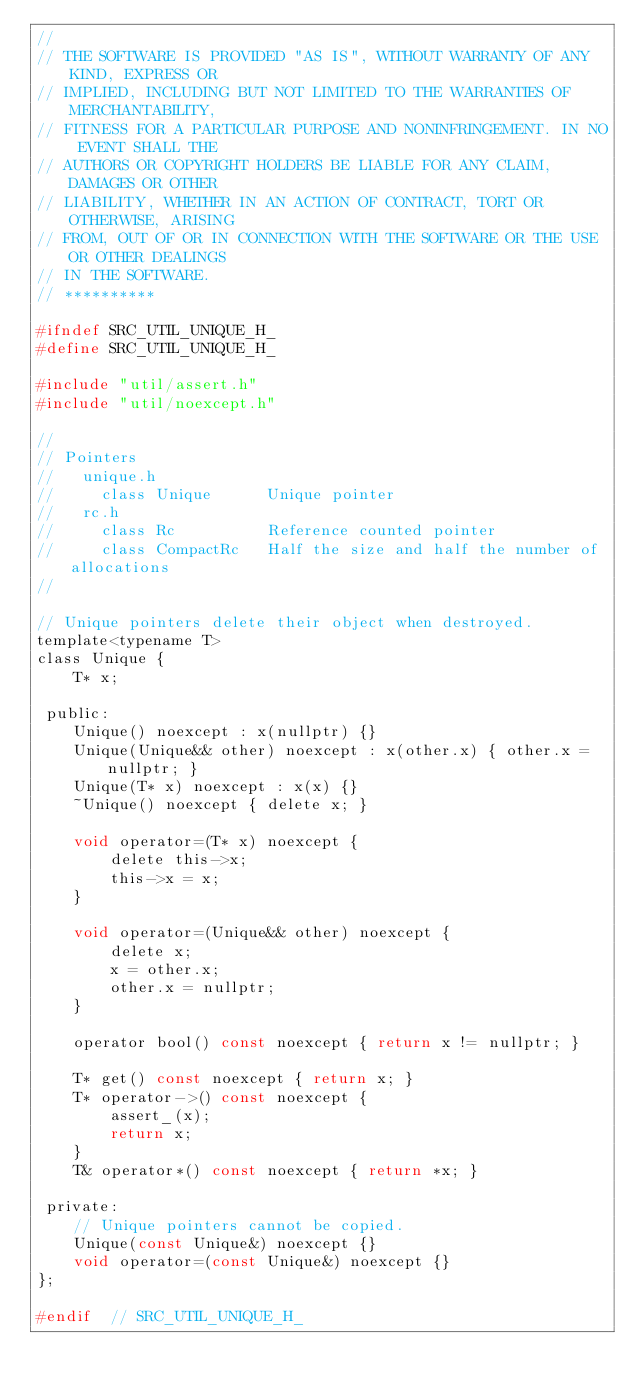Convert code to text. <code><loc_0><loc_0><loc_500><loc_500><_C_>//
// THE SOFTWARE IS PROVIDED "AS IS", WITHOUT WARRANTY OF ANY KIND, EXPRESS OR
// IMPLIED, INCLUDING BUT NOT LIMITED TO THE WARRANTIES OF MERCHANTABILITY,
// FITNESS FOR A PARTICULAR PURPOSE AND NONINFRINGEMENT. IN NO EVENT SHALL THE
// AUTHORS OR COPYRIGHT HOLDERS BE LIABLE FOR ANY CLAIM, DAMAGES OR OTHER
// LIABILITY, WHETHER IN AN ACTION OF CONTRACT, TORT OR OTHERWISE, ARISING
// FROM, OUT OF OR IN CONNECTION WITH THE SOFTWARE OR THE USE OR OTHER DEALINGS
// IN THE SOFTWARE.
// **********

#ifndef SRC_UTIL_UNIQUE_H_
#define SRC_UTIL_UNIQUE_H_

#include "util/assert.h"
#include "util/noexcept.h"

//
// Pointers
//   unique.h
//     class Unique      Unique pointer
//   rc.h
//     class Rc          Reference counted pointer
//     class CompactRc   Half the size and half the number of allocations
//

// Unique pointers delete their object when destroyed.
template<typename T>
class Unique {
    T* x;

 public:
    Unique() noexcept : x(nullptr) {}
    Unique(Unique&& other) noexcept : x(other.x) { other.x = nullptr; }
    Unique(T* x) noexcept : x(x) {}
    ~Unique() noexcept { delete x; }

    void operator=(T* x) noexcept {
        delete this->x;
        this->x = x;
    }

    void operator=(Unique&& other) noexcept {
        delete x;
        x = other.x;
        other.x = nullptr;
    }

    operator bool() const noexcept { return x != nullptr; }

    T* get() const noexcept { return x; }
    T* operator->() const noexcept {
        assert_(x);
        return x;
    }
    T& operator*() const noexcept { return *x; }

 private:
    // Unique pointers cannot be copied.
    Unique(const Unique&) noexcept {}
    void operator=(const Unique&) noexcept {}
};

#endif  // SRC_UTIL_UNIQUE_H_
</code> 